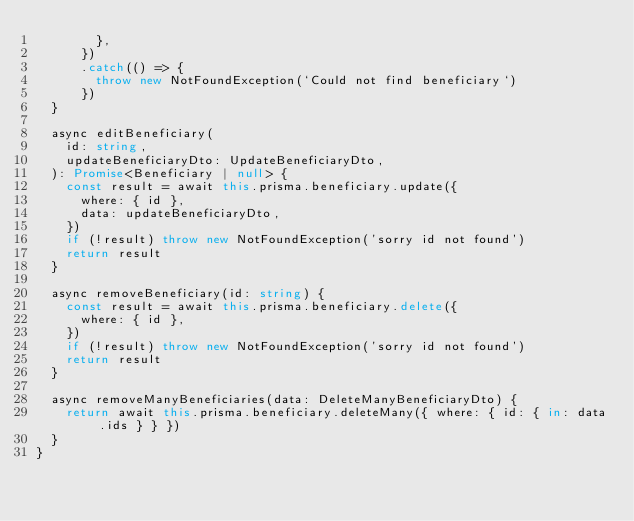Convert code to text. <code><loc_0><loc_0><loc_500><loc_500><_TypeScript_>        },
      })
      .catch(() => {
        throw new NotFoundException(`Could not find beneficiary`)
      })
  }

  async editBeneficiary(
    id: string,
    updateBeneficiaryDto: UpdateBeneficiaryDto,
  ): Promise<Beneficiary | null> {
    const result = await this.prisma.beneficiary.update({
      where: { id },
      data: updateBeneficiaryDto,
    })
    if (!result) throw new NotFoundException('sorry id not found')
    return result
  }

  async removeBeneficiary(id: string) {
    const result = await this.prisma.beneficiary.delete({
      where: { id },
    })
    if (!result) throw new NotFoundException('sorry id not found')
    return result
  }

  async removeManyBeneficiaries(data: DeleteManyBeneficiaryDto) {
    return await this.prisma.beneficiary.deleteMany({ where: { id: { in: data.ids } } })
  }
}
</code> 